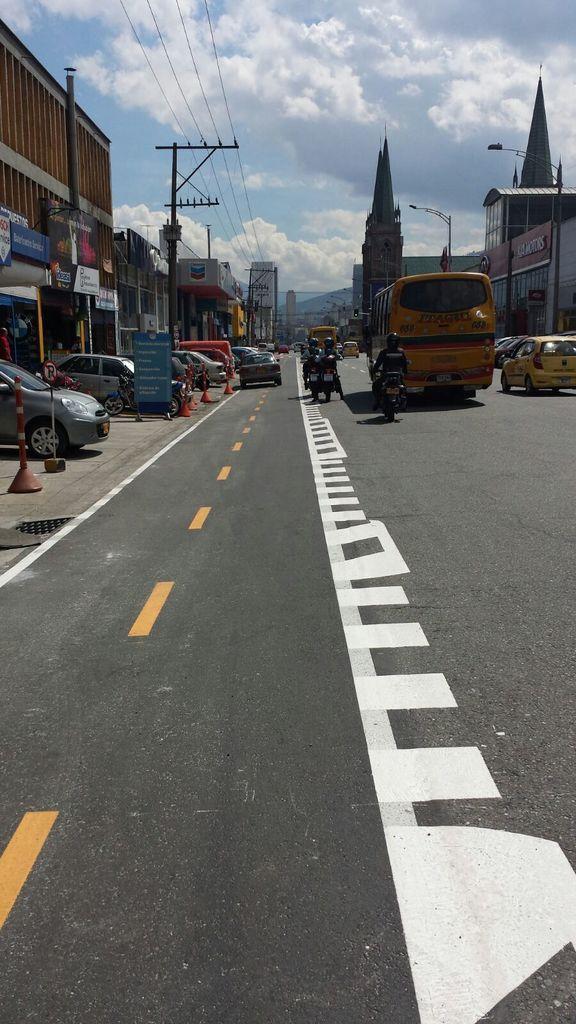How would you summarize this image in a sentence or two? In this image I can see few vehicles on the road and I can see few stalls, buildings, few boards attached to the buildings. Background I can see few electric poles and the sky is in white and blue color. 